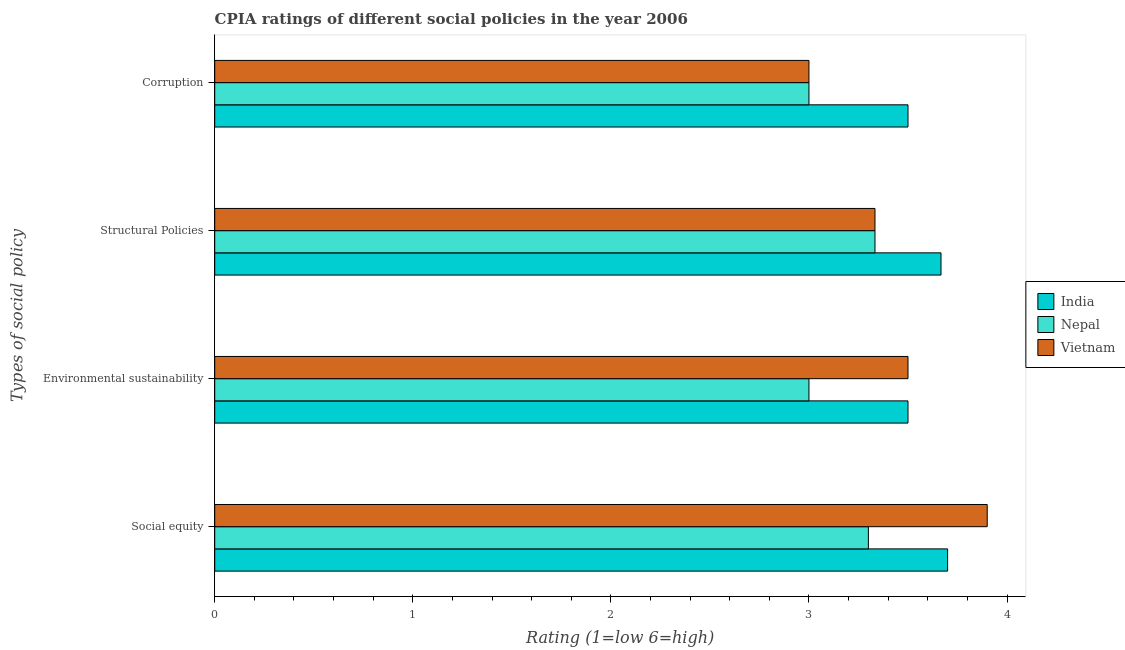Are the number of bars per tick equal to the number of legend labels?
Offer a very short reply. Yes. Are the number of bars on each tick of the Y-axis equal?
Provide a short and direct response. Yes. How many bars are there on the 4th tick from the top?
Make the answer very short. 3. What is the label of the 2nd group of bars from the top?
Give a very brief answer. Structural Policies. Across all countries, what is the maximum cpia rating of structural policies?
Make the answer very short. 3.67. In which country was the cpia rating of social equity maximum?
Ensure brevity in your answer.  Vietnam. In which country was the cpia rating of structural policies minimum?
Your answer should be compact. Nepal. What is the difference between the cpia rating of structural policies in Nepal and that in India?
Your response must be concise. -0.33. What is the difference between the cpia rating of social equity in India and the cpia rating of structural policies in Nepal?
Your answer should be very brief. 0.37. What is the average cpia rating of social equity per country?
Your answer should be compact. 3.63. What is the difference between the cpia rating of corruption and cpia rating of structural policies in India?
Provide a succinct answer. -0.17. What is the ratio of the cpia rating of corruption in Nepal to that in India?
Offer a terse response. 0.86. Is the cpia rating of structural policies in Vietnam less than that in Nepal?
Provide a succinct answer. No. Is the difference between the cpia rating of environmental sustainability in Vietnam and Nepal greater than the difference between the cpia rating of social equity in Vietnam and Nepal?
Ensure brevity in your answer.  No. What is the difference between the highest and the second highest cpia rating of structural policies?
Offer a very short reply. 0.33. What is the difference between the highest and the lowest cpia rating of structural policies?
Give a very brief answer. 0.33. In how many countries, is the cpia rating of social equity greater than the average cpia rating of social equity taken over all countries?
Give a very brief answer. 2. Is the sum of the cpia rating of social equity in India and Vietnam greater than the maximum cpia rating of corruption across all countries?
Provide a succinct answer. Yes. Is it the case that in every country, the sum of the cpia rating of environmental sustainability and cpia rating of structural policies is greater than the sum of cpia rating of social equity and cpia rating of corruption?
Keep it short and to the point. No. What does the 1st bar from the top in Social equity represents?
Your answer should be very brief. Vietnam. What does the 3rd bar from the bottom in Structural Policies represents?
Your answer should be very brief. Vietnam. Are all the bars in the graph horizontal?
Provide a short and direct response. Yes. How many countries are there in the graph?
Your answer should be very brief. 3. Are the values on the major ticks of X-axis written in scientific E-notation?
Provide a succinct answer. No. How many legend labels are there?
Give a very brief answer. 3. How are the legend labels stacked?
Keep it short and to the point. Vertical. What is the title of the graph?
Ensure brevity in your answer.  CPIA ratings of different social policies in the year 2006. What is the label or title of the X-axis?
Provide a short and direct response. Rating (1=low 6=high). What is the label or title of the Y-axis?
Keep it short and to the point. Types of social policy. What is the Rating (1=low 6=high) in Nepal in Social equity?
Your response must be concise. 3.3. What is the Rating (1=low 6=high) in India in Structural Policies?
Provide a succinct answer. 3.67. What is the Rating (1=low 6=high) in Nepal in Structural Policies?
Provide a succinct answer. 3.33. What is the Rating (1=low 6=high) in Vietnam in Structural Policies?
Provide a succinct answer. 3.33. What is the Rating (1=low 6=high) of Nepal in Corruption?
Provide a short and direct response. 3. What is the Rating (1=low 6=high) of Vietnam in Corruption?
Your answer should be compact. 3. Across all Types of social policy, what is the maximum Rating (1=low 6=high) of India?
Offer a terse response. 3.7. Across all Types of social policy, what is the maximum Rating (1=low 6=high) of Nepal?
Ensure brevity in your answer.  3.33. Across all Types of social policy, what is the maximum Rating (1=low 6=high) of Vietnam?
Keep it short and to the point. 3.9. Across all Types of social policy, what is the minimum Rating (1=low 6=high) in India?
Make the answer very short. 3.5. Across all Types of social policy, what is the minimum Rating (1=low 6=high) of Nepal?
Keep it short and to the point. 3. Across all Types of social policy, what is the minimum Rating (1=low 6=high) of Vietnam?
Your response must be concise. 3. What is the total Rating (1=low 6=high) of India in the graph?
Your answer should be very brief. 14.37. What is the total Rating (1=low 6=high) of Nepal in the graph?
Ensure brevity in your answer.  12.63. What is the total Rating (1=low 6=high) in Vietnam in the graph?
Keep it short and to the point. 13.73. What is the difference between the Rating (1=low 6=high) of Nepal in Social equity and that in Environmental sustainability?
Provide a succinct answer. 0.3. What is the difference between the Rating (1=low 6=high) of India in Social equity and that in Structural Policies?
Provide a succinct answer. 0.03. What is the difference between the Rating (1=low 6=high) of Nepal in Social equity and that in Structural Policies?
Your response must be concise. -0.03. What is the difference between the Rating (1=low 6=high) in Vietnam in Social equity and that in Structural Policies?
Your answer should be very brief. 0.57. What is the difference between the Rating (1=low 6=high) of India in Social equity and that in Corruption?
Give a very brief answer. 0.2. What is the difference between the Rating (1=low 6=high) in Vietnam in Social equity and that in Corruption?
Keep it short and to the point. 0.9. What is the difference between the Rating (1=low 6=high) in India in Environmental sustainability and that in Structural Policies?
Ensure brevity in your answer.  -0.17. What is the difference between the Rating (1=low 6=high) of Nepal in Structural Policies and that in Corruption?
Offer a very short reply. 0.33. What is the difference between the Rating (1=low 6=high) of Vietnam in Structural Policies and that in Corruption?
Your answer should be very brief. 0.33. What is the difference between the Rating (1=low 6=high) of India in Social equity and the Rating (1=low 6=high) of Vietnam in Environmental sustainability?
Provide a succinct answer. 0.2. What is the difference between the Rating (1=low 6=high) in India in Social equity and the Rating (1=low 6=high) in Nepal in Structural Policies?
Ensure brevity in your answer.  0.37. What is the difference between the Rating (1=low 6=high) in India in Social equity and the Rating (1=low 6=high) in Vietnam in Structural Policies?
Make the answer very short. 0.37. What is the difference between the Rating (1=low 6=high) in Nepal in Social equity and the Rating (1=low 6=high) in Vietnam in Structural Policies?
Ensure brevity in your answer.  -0.03. What is the difference between the Rating (1=low 6=high) of India in Social equity and the Rating (1=low 6=high) of Vietnam in Corruption?
Your answer should be compact. 0.7. What is the difference between the Rating (1=low 6=high) in Nepal in Social equity and the Rating (1=low 6=high) in Vietnam in Corruption?
Your answer should be very brief. 0.3. What is the difference between the Rating (1=low 6=high) of India in Environmental sustainability and the Rating (1=low 6=high) of Nepal in Structural Policies?
Provide a short and direct response. 0.17. What is the difference between the Rating (1=low 6=high) in India in Environmental sustainability and the Rating (1=low 6=high) in Vietnam in Structural Policies?
Offer a very short reply. 0.17. What is the difference between the Rating (1=low 6=high) of Nepal in Environmental sustainability and the Rating (1=low 6=high) of Vietnam in Structural Policies?
Provide a succinct answer. -0.33. What is the difference between the Rating (1=low 6=high) in India in Environmental sustainability and the Rating (1=low 6=high) in Nepal in Corruption?
Provide a succinct answer. 0.5. What is the average Rating (1=low 6=high) of India per Types of social policy?
Make the answer very short. 3.59. What is the average Rating (1=low 6=high) in Nepal per Types of social policy?
Ensure brevity in your answer.  3.16. What is the average Rating (1=low 6=high) in Vietnam per Types of social policy?
Keep it short and to the point. 3.43. What is the difference between the Rating (1=low 6=high) in India and Rating (1=low 6=high) in Nepal in Social equity?
Your answer should be compact. 0.4. What is the difference between the Rating (1=low 6=high) in Nepal and Rating (1=low 6=high) in Vietnam in Social equity?
Make the answer very short. -0.6. What is the difference between the Rating (1=low 6=high) of India and Rating (1=low 6=high) of Nepal in Environmental sustainability?
Provide a succinct answer. 0.5. What is the difference between the Rating (1=low 6=high) in India and Rating (1=low 6=high) in Vietnam in Environmental sustainability?
Make the answer very short. 0. What is the difference between the Rating (1=low 6=high) in India and Rating (1=low 6=high) in Vietnam in Structural Policies?
Offer a terse response. 0.33. What is the difference between the Rating (1=low 6=high) of India and Rating (1=low 6=high) of Vietnam in Corruption?
Ensure brevity in your answer.  0.5. What is the difference between the Rating (1=low 6=high) in Nepal and Rating (1=low 6=high) in Vietnam in Corruption?
Offer a very short reply. 0. What is the ratio of the Rating (1=low 6=high) in India in Social equity to that in Environmental sustainability?
Ensure brevity in your answer.  1.06. What is the ratio of the Rating (1=low 6=high) in Nepal in Social equity to that in Environmental sustainability?
Your response must be concise. 1.1. What is the ratio of the Rating (1=low 6=high) of Vietnam in Social equity to that in Environmental sustainability?
Provide a succinct answer. 1.11. What is the ratio of the Rating (1=low 6=high) of India in Social equity to that in Structural Policies?
Give a very brief answer. 1.01. What is the ratio of the Rating (1=low 6=high) of Nepal in Social equity to that in Structural Policies?
Make the answer very short. 0.99. What is the ratio of the Rating (1=low 6=high) of Vietnam in Social equity to that in Structural Policies?
Ensure brevity in your answer.  1.17. What is the ratio of the Rating (1=low 6=high) of India in Social equity to that in Corruption?
Give a very brief answer. 1.06. What is the ratio of the Rating (1=low 6=high) of Nepal in Social equity to that in Corruption?
Offer a terse response. 1.1. What is the ratio of the Rating (1=low 6=high) in India in Environmental sustainability to that in Structural Policies?
Your answer should be compact. 0.95. What is the ratio of the Rating (1=low 6=high) of Nepal in Environmental sustainability to that in Structural Policies?
Make the answer very short. 0.9. What is the ratio of the Rating (1=low 6=high) in India in Environmental sustainability to that in Corruption?
Give a very brief answer. 1. What is the ratio of the Rating (1=low 6=high) of Vietnam in Environmental sustainability to that in Corruption?
Provide a short and direct response. 1.17. What is the ratio of the Rating (1=low 6=high) of India in Structural Policies to that in Corruption?
Offer a terse response. 1.05. What is the ratio of the Rating (1=low 6=high) of Vietnam in Structural Policies to that in Corruption?
Ensure brevity in your answer.  1.11. What is the difference between the highest and the second highest Rating (1=low 6=high) in Nepal?
Ensure brevity in your answer.  0.03. What is the difference between the highest and the second highest Rating (1=low 6=high) of Vietnam?
Give a very brief answer. 0.4. What is the difference between the highest and the lowest Rating (1=low 6=high) in Nepal?
Your answer should be compact. 0.33. 